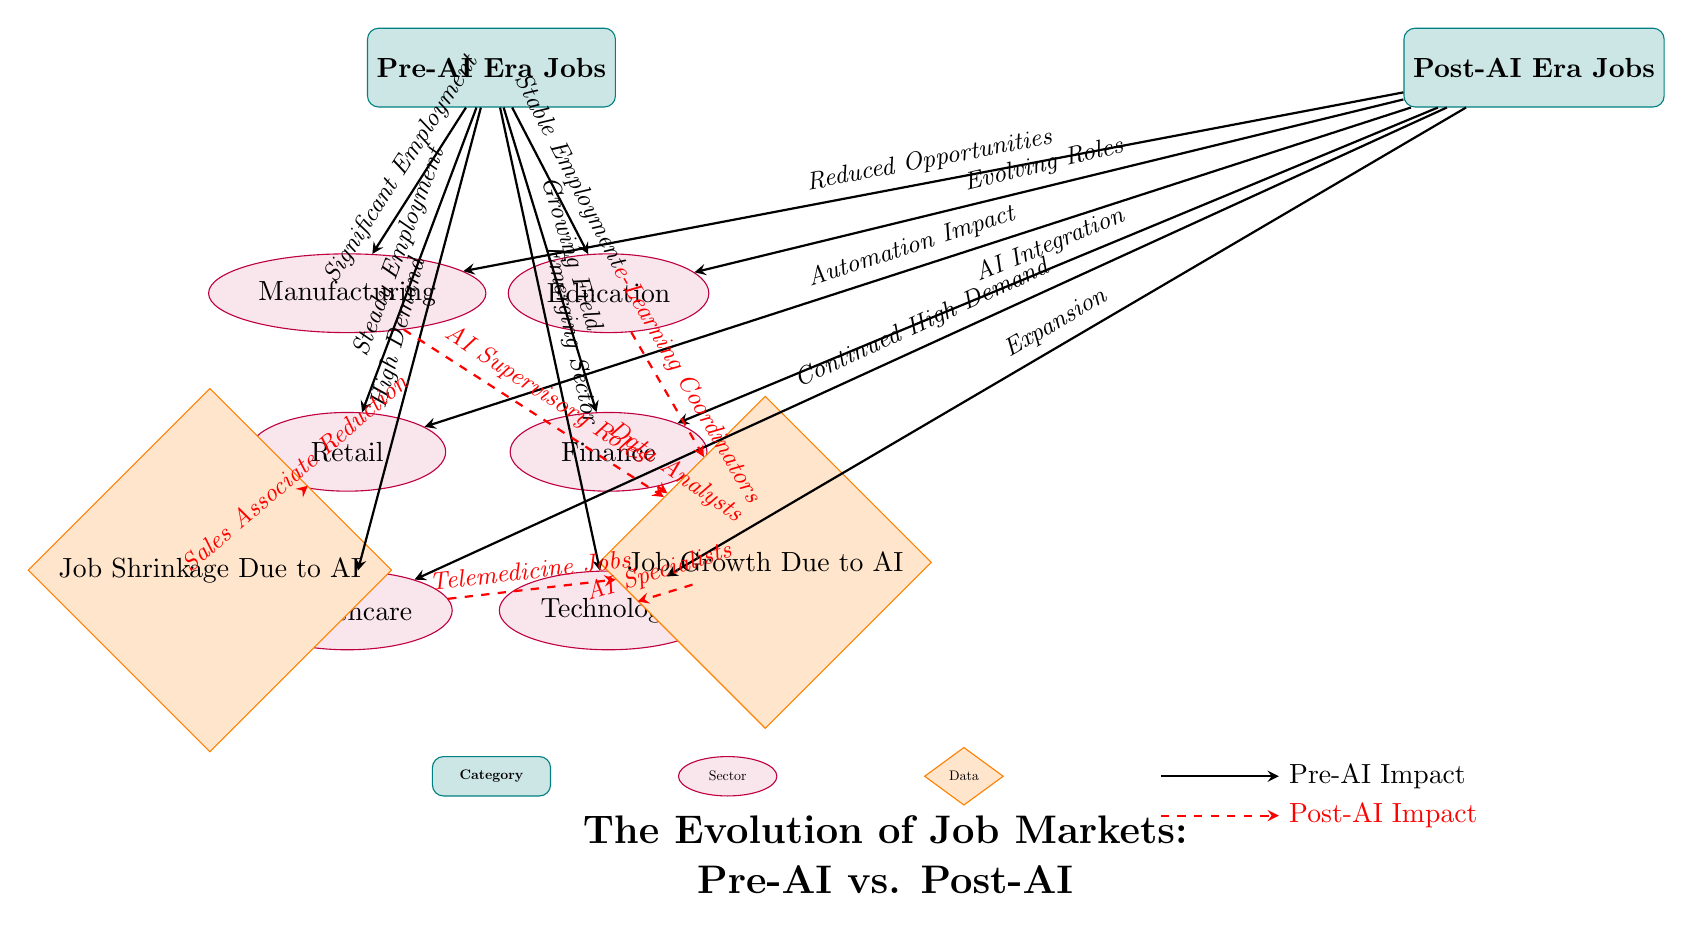What job sector had significant employment in the Pre-AI era? The arrow labeled "Significant Employment" from "Pre-AI Era Jobs" points to the "Manufacturing" sector, indicating it had a significant number of jobs during that period.
Answer: Manufacturing Which sector is expected to see job shrinkage due to AI? The arrow labeled "Sales Associate Reduction" points from "Retail" to "Job Shrinkage Due to AI," indicating a reduction in job opportunities in this sector due to AI impacts.
Answer: Retail What type of jobs has continued high demand in the Post-AI era? The arrow labeled "Continued High Demand" coming from "Healthcare" points toward the "Post-AI Era Jobs," showing that this sector maintains high job demand even after AI introduction.
Answer: Healthcare How many job categories are represented in the diagram? The diagram lists six job sectors under "Pre-AI Era Jobs" and six under "Post-AI Era Jobs," totaling twelve categories represented in the diagram.
Answer: Twelve What is one role expected to emerge in the Post-AI era from the finance sector? The arrow labeled "Data Analysts" comes from the "Finance" sector leading to "Job Growth Due to AI," indicating that data analysts are expected to emerge due to AI influences in this sector.
Answer: Data Analysts Which sector shows an expansion in the Post-AI era? The arrow labeled "Expansion" points from the "Technology" sector in the Post-AI era, indicating that this sector is expected to grow significantly due to AI advancements.
Answer: Technology What kind of roles are anticipated to emerge from the manufacturing sector due to AI? The dashed red arrow labeled "AI Supervisory Roles" indicates that new supervisory roles connected to AI within manufacturing are expected to grow, following AI implementation.
Answer: AI Supervisory Roles What change does the healthcare sector experience as a result of AI? The arrow labeled "Telemedicine Jobs" from "Healthcare" to "Job Growth Due to AI" shows that AI is leading to the growth of telemedicine jobs in the healthcare sector.
Answer: Telemedicine Jobs 